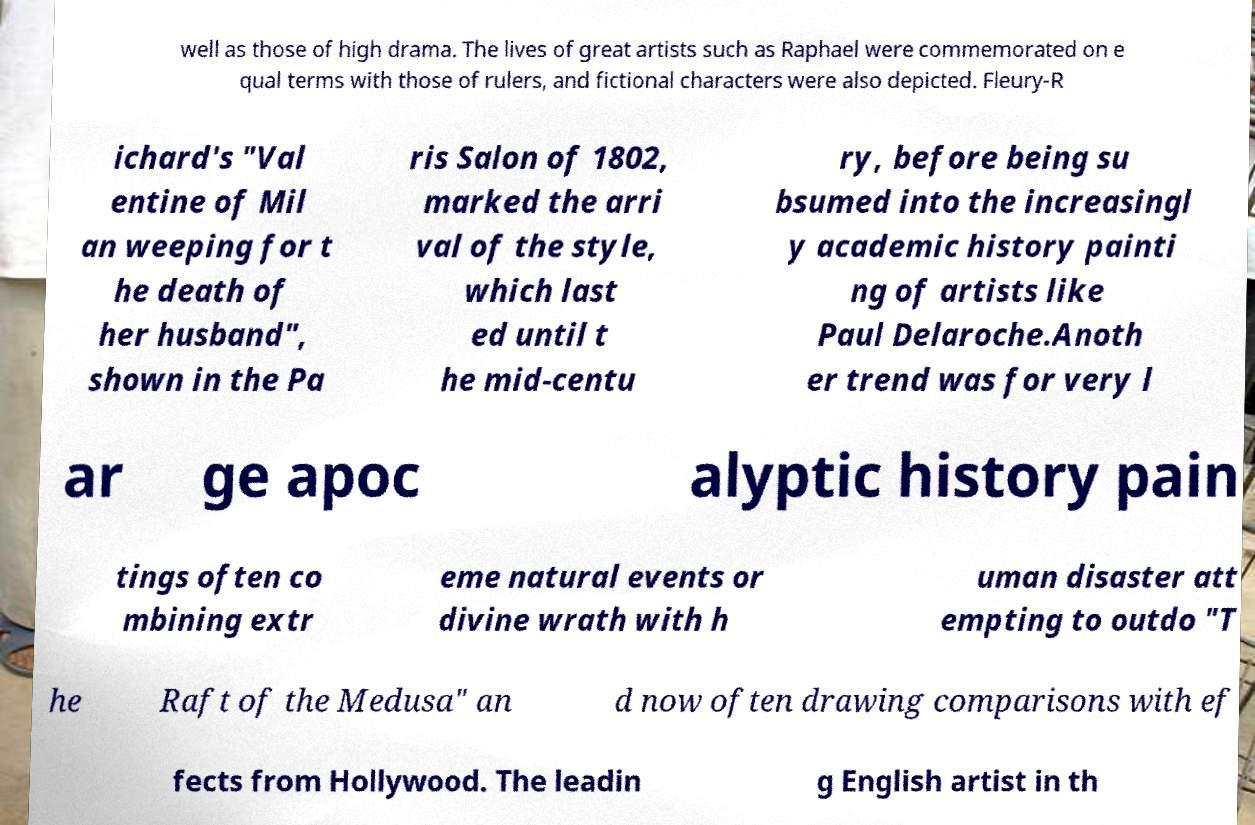Please identify and transcribe the text found in this image. well as those of high drama. The lives of great artists such as Raphael were commemorated on e qual terms with those of rulers, and fictional characters were also depicted. Fleury-R ichard's "Val entine of Mil an weeping for t he death of her husband", shown in the Pa ris Salon of 1802, marked the arri val of the style, which last ed until t he mid-centu ry, before being su bsumed into the increasingl y academic history painti ng of artists like Paul Delaroche.Anoth er trend was for very l ar ge apoc alyptic history pain tings often co mbining extr eme natural events or divine wrath with h uman disaster att empting to outdo "T he Raft of the Medusa" an d now often drawing comparisons with ef fects from Hollywood. The leadin g English artist in th 